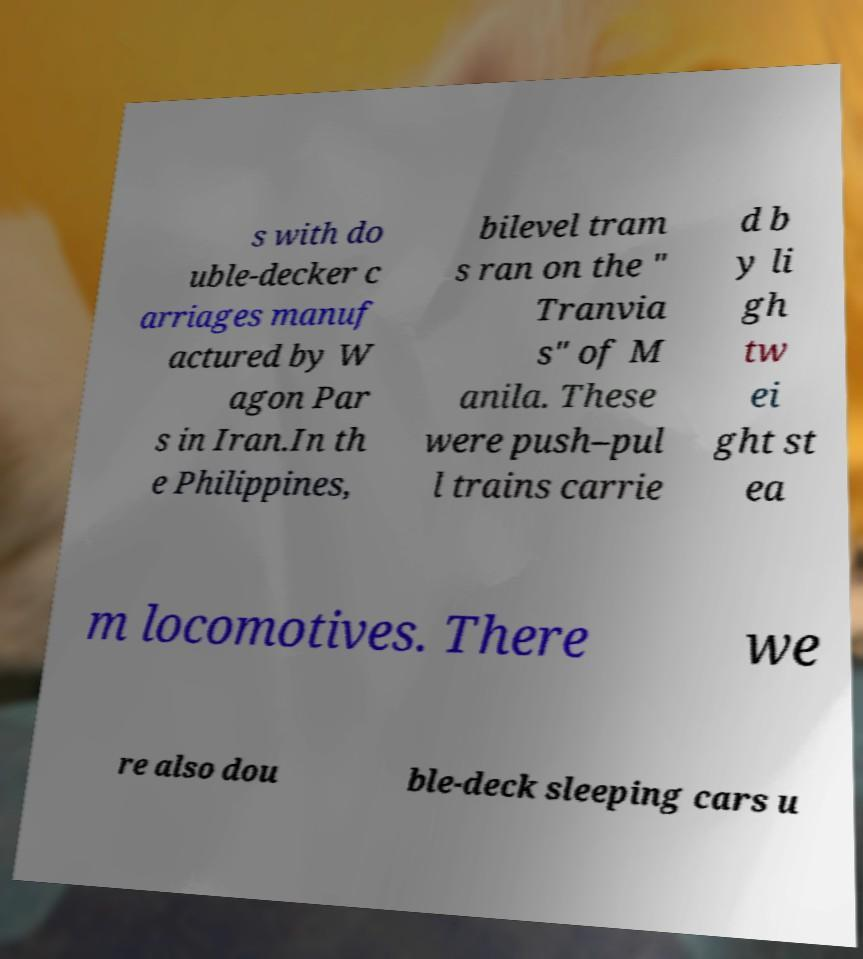There's text embedded in this image that I need extracted. Can you transcribe it verbatim? s with do uble-decker c arriages manuf actured by W agon Par s in Iran.In th e Philippines, bilevel tram s ran on the " Tranvia s" of M anila. These were push–pul l trains carrie d b y li gh tw ei ght st ea m locomotives. There we re also dou ble-deck sleeping cars u 